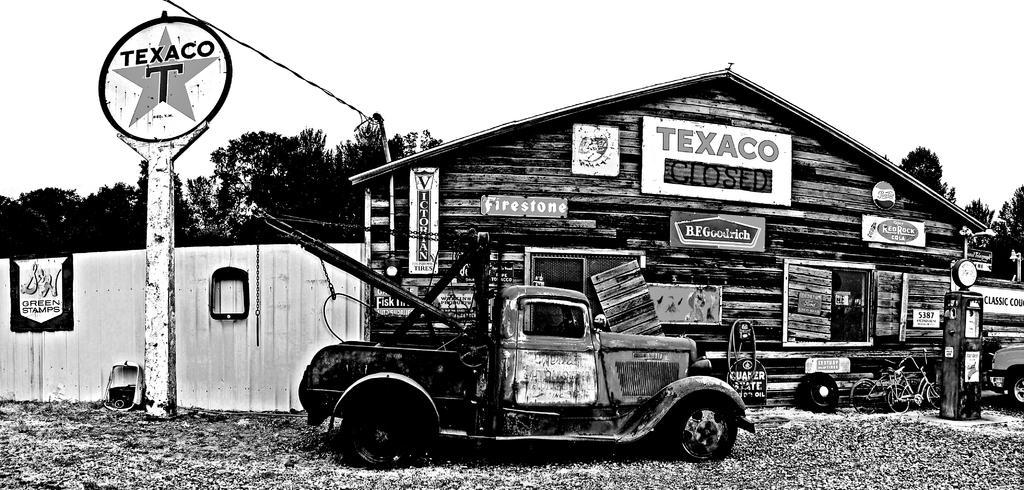How would you summarize this image in a sentence or two? In this image I can see a vehicle in the front. In the background I can see a building, a pole, a wire, number of boards, number of trees, two bicycles and on these boards I can see something is written. On the right side of the image I can see an object and one more vehicle. I can also see this image is black and white in colour. 